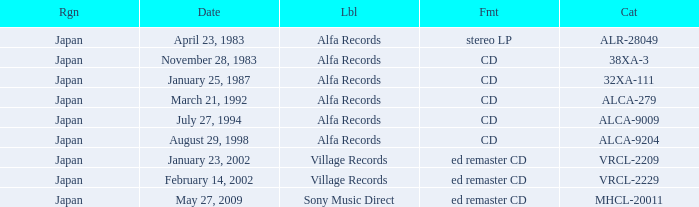Which date is in CD format? November 28, 1983, January 25, 1987, March 21, 1992, July 27, 1994, August 29, 1998. 